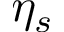Convert formula to latex. <formula><loc_0><loc_0><loc_500><loc_500>\eta _ { s }</formula> 